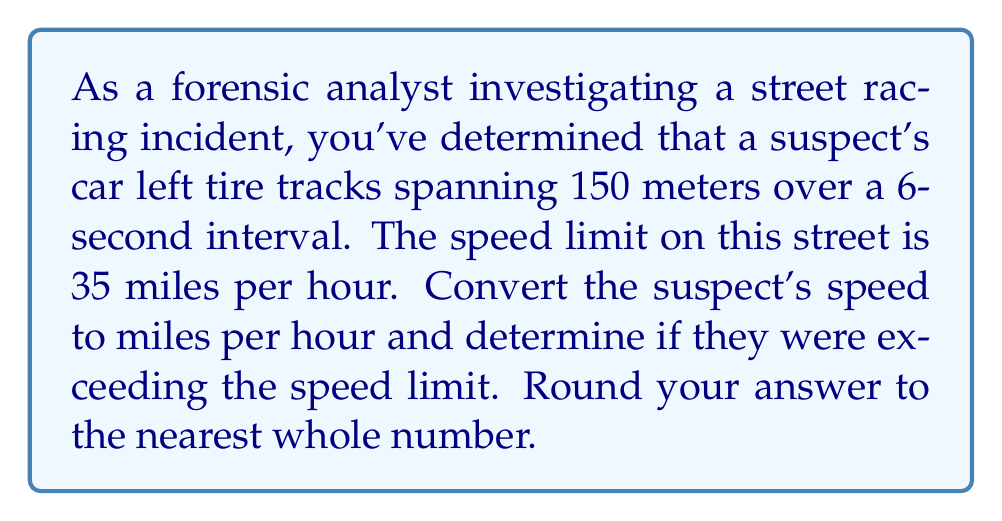Could you help me with this problem? To solve this problem, we need to follow these steps:

1. Calculate the speed in meters per second:
   $$\text{Speed} = \frac{\text{Distance}}{\text{Time}} = \frac{150 \text{ m}}{6 \text{ s}} = 25 \text{ m/s}$$

2. Convert meters per second to kilometers per hour:
   $$25 \text{ m/s} \times \frac{3600 \text{ s}}{1 \text{ h}} \times \frac{1 \text{ km}}{1000 \text{ m}} = 90 \text{ km/h}$$

3. Convert kilometers per hour to miles per hour:
   $$90 \text{ km/h} \times \frac{1 \text{ mile}}{1.60934 \text{ km}} \approx 55.92 \text{ mph}$$

4. Round to the nearest whole number:
   $$55.92 \text{ mph} \approx 56 \text{ mph}$$

5. Compare to the speed limit:
   The speed limit is 35 mph, and the calculated speed is 56 mph.
   $$56 \text{ mph} > 35 \text{ mph}$$

Therefore, the suspect was exceeding the speed limit.
Answer: 56 mph, which exceeds the speed limit of 35 mph. 